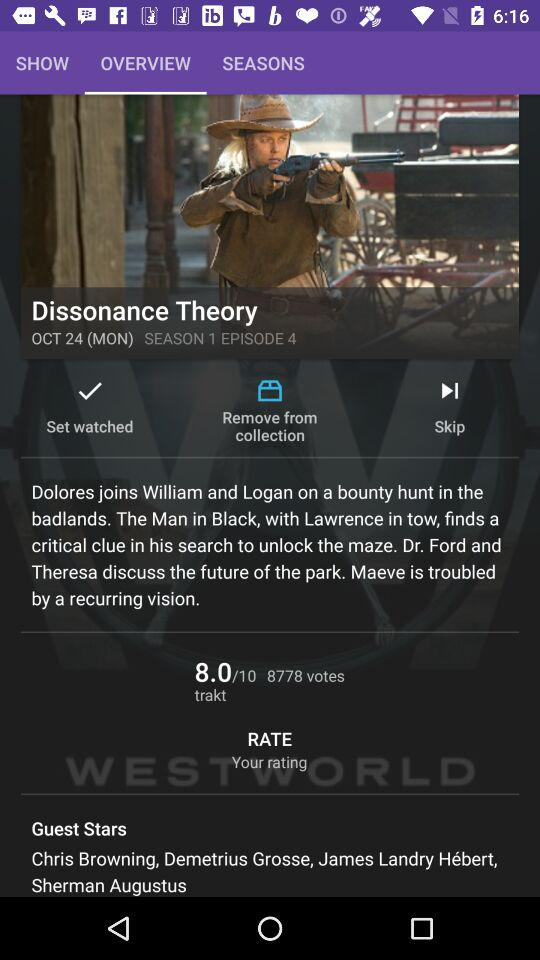What month is it? The month is October. 